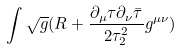Convert formula to latex. <formula><loc_0><loc_0><loc_500><loc_500>\int \sqrt { g } ( R + \frac { \partial _ { \mu } \tau \partial _ { \nu } \bar { \tau } } { 2 \tau ^ { 2 } _ { 2 } } g ^ { \mu \nu } )</formula> 